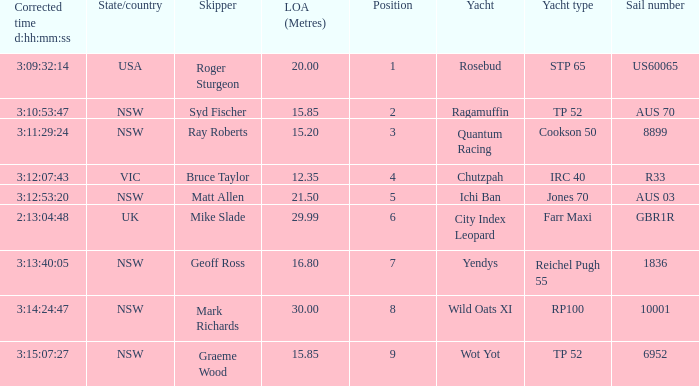What are all of the states or countries with a corrected time 3:13:40:05? NSW. 